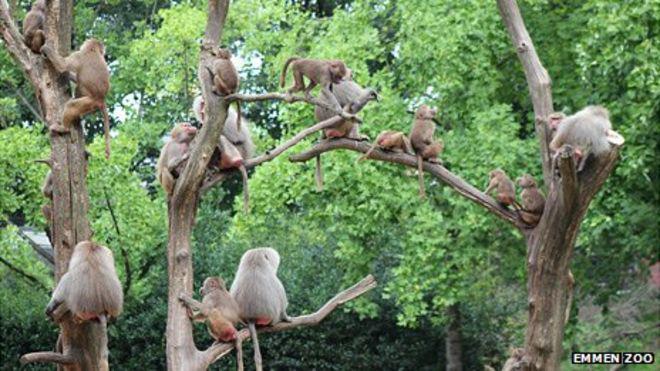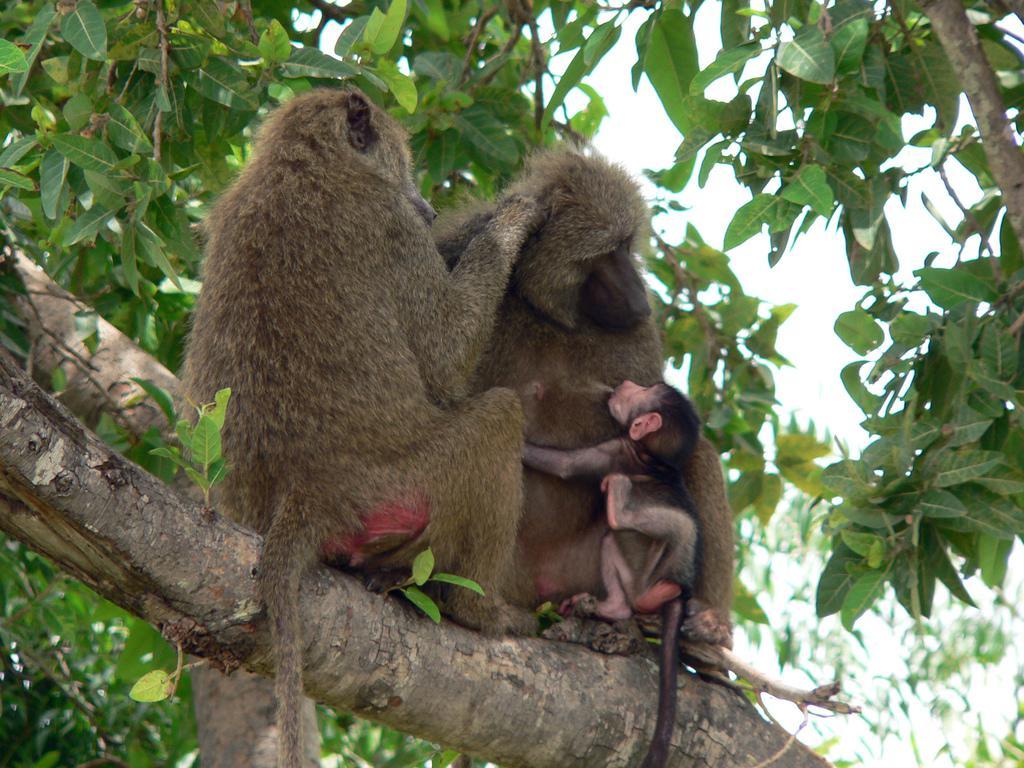The first image is the image on the left, the second image is the image on the right. Given the left and right images, does the statement "The monkeys in each of the images are sitting in the trees." hold true? Answer yes or no. Yes. The first image is the image on the left, the second image is the image on the right. Given the left and right images, does the statement "All baboons are pictured in the branches of trees, and baboons of different ages are included in the combined images." hold true? Answer yes or no. Yes. 